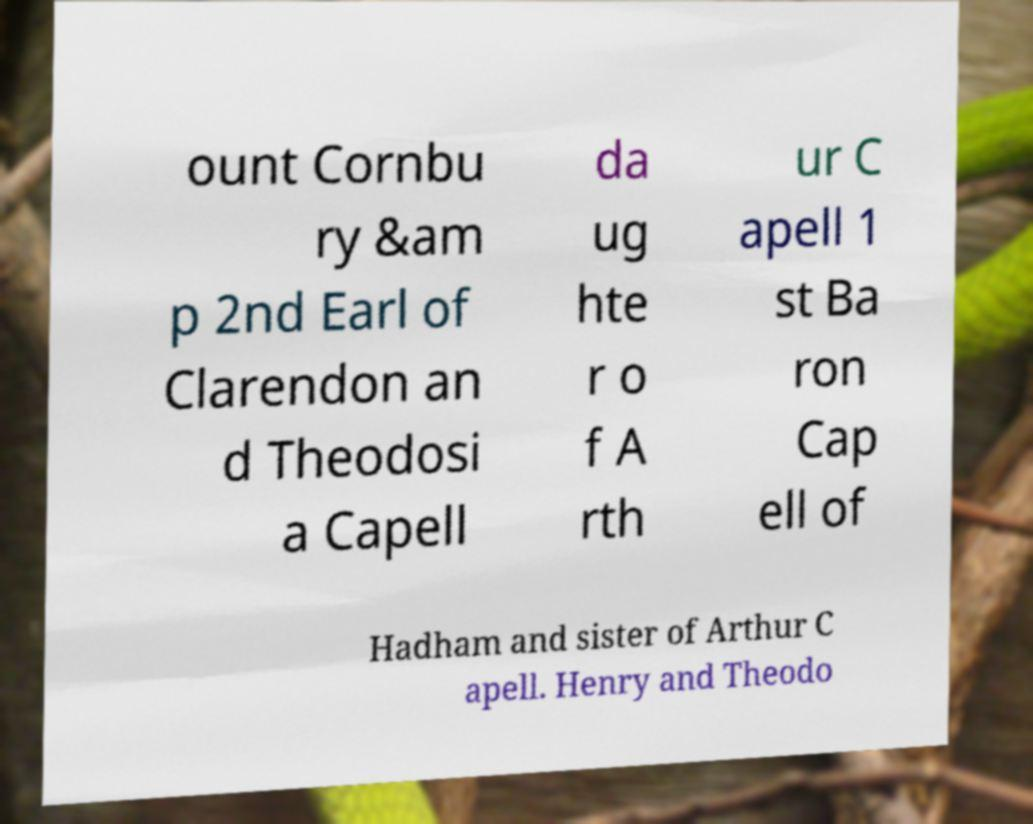Could you assist in decoding the text presented in this image and type it out clearly? ount Cornbu ry &am p 2nd Earl of Clarendon an d Theodosi a Capell da ug hte r o f A rth ur C apell 1 st Ba ron Cap ell of Hadham and sister of Arthur C apell. Henry and Theodo 